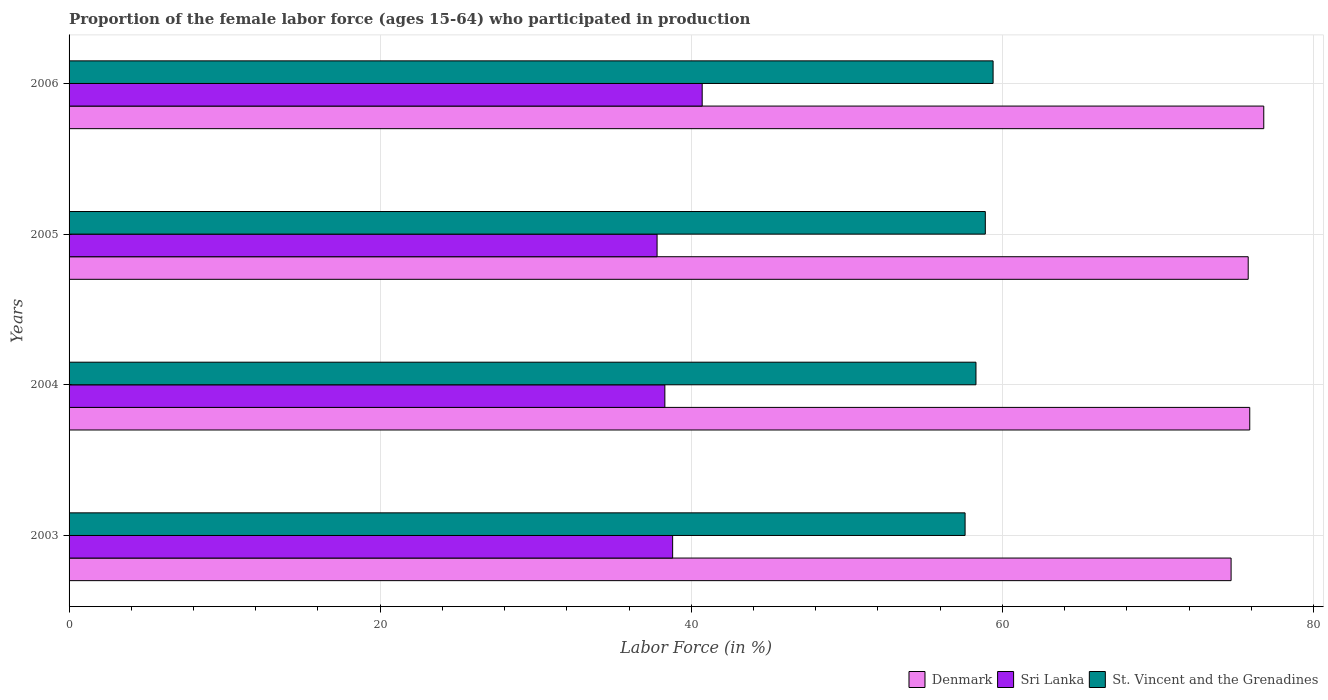How many different coloured bars are there?
Provide a short and direct response. 3. Are the number of bars per tick equal to the number of legend labels?
Make the answer very short. Yes. How many bars are there on the 2nd tick from the top?
Your answer should be very brief. 3. What is the label of the 2nd group of bars from the top?
Give a very brief answer. 2005. In how many cases, is the number of bars for a given year not equal to the number of legend labels?
Offer a terse response. 0. What is the proportion of the female labor force who participated in production in Denmark in 2004?
Keep it short and to the point. 75.9. Across all years, what is the maximum proportion of the female labor force who participated in production in Sri Lanka?
Your answer should be compact. 40.7. Across all years, what is the minimum proportion of the female labor force who participated in production in St. Vincent and the Grenadines?
Make the answer very short. 57.6. In which year was the proportion of the female labor force who participated in production in Denmark maximum?
Offer a terse response. 2006. What is the total proportion of the female labor force who participated in production in Sri Lanka in the graph?
Your answer should be compact. 155.6. What is the difference between the proportion of the female labor force who participated in production in Denmark in 2004 and that in 2006?
Provide a short and direct response. -0.9. What is the difference between the proportion of the female labor force who participated in production in St. Vincent and the Grenadines in 2004 and the proportion of the female labor force who participated in production in Denmark in 2006?
Your answer should be very brief. -18.5. What is the average proportion of the female labor force who participated in production in Denmark per year?
Your answer should be very brief. 75.8. In the year 2005, what is the difference between the proportion of the female labor force who participated in production in Denmark and proportion of the female labor force who participated in production in Sri Lanka?
Offer a very short reply. 38. In how many years, is the proportion of the female labor force who participated in production in Sri Lanka greater than 12 %?
Your answer should be compact. 4. What is the ratio of the proportion of the female labor force who participated in production in Sri Lanka in 2003 to that in 2006?
Provide a succinct answer. 0.95. What is the difference between the highest and the second highest proportion of the female labor force who participated in production in Denmark?
Keep it short and to the point. 0.9. What is the difference between the highest and the lowest proportion of the female labor force who participated in production in Denmark?
Offer a terse response. 2.1. In how many years, is the proportion of the female labor force who participated in production in Sri Lanka greater than the average proportion of the female labor force who participated in production in Sri Lanka taken over all years?
Your answer should be very brief. 1. Is the sum of the proportion of the female labor force who participated in production in Sri Lanka in 2005 and 2006 greater than the maximum proportion of the female labor force who participated in production in Denmark across all years?
Your answer should be very brief. Yes. What does the 1st bar from the top in 2005 represents?
Give a very brief answer. St. Vincent and the Grenadines. What does the 2nd bar from the bottom in 2006 represents?
Your answer should be very brief. Sri Lanka. Is it the case that in every year, the sum of the proportion of the female labor force who participated in production in Sri Lanka and proportion of the female labor force who participated in production in Denmark is greater than the proportion of the female labor force who participated in production in St. Vincent and the Grenadines?
Your response must be concise. Yes. Are all the bars in the graph horizontal?
Your response must be concise. Yes. How many years are there in the graph?
Give a very brief answer. 4. Are the values on the major ticks of X-axis written in scientific E-notation?
Offer a very short reply. No. Where does the legend appear in the graph?
Your response must be concise. Bottom right. How many legend labels are there?
Ensure brevity in your answer.  3. What is the title of the graph?
Give a very brief answer. Proportion of the female labor force (ages 15-64) who participated in production. What is the label or title of the Y-axis?
Provide a succinct answer. Years. What is the Labor Force (in %) of Denmark in 2003?
Provide a short and direct response. 74.7. What is the Labor Force (in %) in Sri Lanka in 2003?
Provide a succinct answer. 38.8. What is the Labor Force (in %) of St. Vincent and the Grenadines in 2003?
Offer a terse response. 57.6. What is the Labor Force (in %) of Denmark in 2004?
Offer a very short reply. 75.9. What is the Labor Force (in %) in Sri Lanka in 2004?
Offer a very short reply. 38.3. What is the Labor Force (in %) in St. Vincent and the Grenadines in 2004?
Your answer should be very brief. 58.3. What is the Labor Force (in %) in Denmark in 2005?
Keep it short and to the point. 75.8. What is the Labor Force (in %) of Sri Lanka in 2005?
Make the answer very short. 37.8. What is the Labor Force (in %) of St. Vincent and the Grenadines in 2005?
Your answer should be very brief. 58.9. What is the Labor Force (in %) of Denmark in 2006?
Provide a succinct answer. 76.8. What is the Labor Force (in %) of Sri Lanka in 2006?
Ensure brevity in your answer.  40.7. What is the Labor Force (in %) in St. Vincent and the Grenadines in 2006?
Your response must be concise. 59.4. Across all years, what is the maximum Labor Force (in %) of Denmark?
Provide a short and direct response. 76.8. Across all years, what is the maximum Labor Force (in %) in Sri Lanka?
Make the answer very short. 40.7. Across all years, what is the maximum Labor Force (in %) of St. Vincent and the Grenadines?
Make the answer very short. 59.4. Across all years, what is the minimum Labor Force (in %) of Denmark?
Make the answer very short. 74.7. Across all years, what is the minimum Labor Force (in %) of Sri Lanka?
Your response must be concise. 37.8. Across all years, what is the minimum Labor Force (in %) in St. Vincent and the Grenadines?
Ensure brevity in your answer.  57.6. What is the total Labor Force (in %) of Denmark in the graph?
Make the answer very short. 303.2. What is the total Labor Force (in %) in Sri Lanka in the graph?
Ensure brevity in your answer.  155.6. What is the total Labor Force (in %) of St. Vincent and the Grenadines in the graph?
Provide a succinct answer. 234.2. What is the difference between the Labor Force (in %) in Denmark in 2003 and that in 2004?
Offer a very short reply. -1.2. What is the difference between the Labor Force (in %) of St. Vincent and the Grenadines in 2003 and that in 2005?
Provide a short and direct response. -1.3. What is the difference between the Labor Force (in %) in St. Vincent and the Grenadines in 2003 and that in 2006?
Keep it short and to the point. -1.8. What is the difference between the Labor Force (in %) in St. Vincent and the Grenadines in 2004 and that in 2005?
Provide a succinct answer. -0.6. What is the difference between the Labor Force (in %) of Sri Lanka in 2004 and that in 2006?
Your answer should be compact. -2.4. What is the difference between the Labor Force (in %) in Denmark in 2005 and that in 2006?
Your answer should be compact. -1. What is the difference between the Labor Force (in %) of Sri Lanka in 2005 and that in 2006?
Your response must be concise. -2.9. What is the difference between the Labor Force (in %) of Denmark in 2003 and the Labor Force (in %) of Sri Lanka in 2004?
Offer a terse response. 36.4. What is the difference between the Labor Force (in %) in Denmark in 2003 and the Labor Force (in %) in St. Vincent and the Grenadines in 2004?
Keep it short and to the point. 16.4. What is the difference between the Labor Force (in %) in Sri Lanka in 2003 and the Labor Force (in %) in St. Vincent and the Grenadines in 2004?
Your response must be concise. -19.5. What is the difference between the Labor Force (in %) of Denmark in 2003 and the Labor Force (in %) of Sri Lanka in 2005?
Your answer should be very brief. 36.9. What is the difference between the Labor Force (in %) in Sri Lanka in 2003 and the Labor Force (in %) in St. Vincent and the Grenadines in 2005?
Keep it short and to the point. -20.1. What is the difference between the Labor Force (in %) of Denmark in 2003 and the Labor Force (in %) of Sri Lanka in 2006?
Offer a very short reply. 34. What is the difference between the Labor Force (in %) of Denmark in 2003 and the Labor Force (in %) of St. Vincent and the Grenadines in 2006?
Make the answer very short. 15.3. What is the difference between the Labor Force (in %) of Sri Lanka in 2003 and the Labor Force (in %) of St. Vincent and the Grenadines in 2006?
Offer a terse response. -20.6. What is the difference between the Labor Force (in %) in Denmark in 2004 and the Labor Force (in %) in Sri Lanka in 2005?
Provide a short and direct response. 38.1. What is the difference between the Labor Force (in %) of Sri Lanka in 2004 and the Labor Force (in %) of St. Vincent and the Grenadines in 2005?
Your answer should be compact. -20.6. What is the difference between the Labor Force (in %) of Denmark in 2004 and the Labor Force (in %) of Sri Lanka in 2006?
Your response must be concise. 35.2. What is the difference between the Labor Force (in %) of Denmark in 2004 and the Labor Force (in %) of St. Vincent and the Grenadines in 2006?
Your response must be concise. 16.5. What is the difference between the Labor Force (in %) of Sri Lanka in 2004 and the Labor Force (in %) of St. Vincent and the Grenadines in 2006?
Ensure brevity in your answer.  -21.1. What is the difference between the Labor Force (in %) in Denmark in 2005 and the Labor Force (in %) in Sri Lanka in 2006?
Your answer should be very brief. 35.1. What is the difference between the Labor Force (in %) in Denmark in 2005 and the Labor Force (in %) in St. Vincent and the Grenadines in 2006?
Provide a short and direct response. 16.4. What is the difference between the Labor Force (in %) in Sri Lanka in 2005 and the Labor Force (in %) in St. Vincent and the Grenadines in 2006?
Keep it short and to the point. -21.6. What is the average Labor Force (in %) of Denmark per year?
Give a very brief answer. 75.8. What is the average Labor Force (in %) in Sri Lanka per year?
Offer a very short reply. 38.9. What is the average Labor Force (in %) in St. Vincent and the Grenadines per year?
Offer a very short reply. 58.55. In the year 2003, what is the difference between the Labor Force (in %) of Denmark and Labor Force (in %) of Sri Lanka?
Offer a terse response. 35.9. In the year 2003, what is the difference between the Labor Force (in %) in Denmark and Labor Force (in %) in St. Vincent and the Grenadines?
Your response must be concise. 17.1. In the year 2003, what is the difference between the Labor Force (in %) in Sri Lanka and Labor Force (in %) in St. Vincent and the Grenadines?
Your answer should be very brief. -18.8. In the year 2004, what is the difference between the Labor Force (in %) of Denmark and Labor Force (in %) of Sri Lanka?
Make the answer very short. 37.6. In the year 2004, what is the difference between the Labor Force (in %) in Denmark and Labor Force (in %) in St. Vincent and the Grenadines?
Provide a short and direct response. 17.6. In the year 2004, what is the difference between the Labor Force (in %) of Sri Lanka and Labor Force (in %) of St. Vincent and the Grenadines?
Your response must be concise. -20. In the year 2005, what is the difference between the Labor Force (in %) in Denmark and Labor Force (in %) in Sri Lanka?
Your answer should be compact. 38. In the year 2005, what is the difference between the Labor Force (in %) in Sri Lanka and Labor Force (in %) in St. Vincent and the Grenadines?
Keep it short and to the point. -21.1. In the year 2006, what is the difference between the Labor Force (in %) of Denmark and Labor Force (in %) of Sri Lanka?
Offer a terse response. 36.1. In the year 2006, what is the difference between the Labor Force (in %) in Sri Lanka and Labor Force (in %) in St. Vincent and the Grenadines?
Provide a short and direct response. -18.7. What is the ratio of the Labor Force (in %) of Denmark in 2003 to that in 2004?
Provide a short and direct response. 0.98. What is the ratio of the Labor Force (in %) of Sri Lanka in 2003 to that in 2004?
Ensure brevity in your answer.  1.01. What is the ratio of the Labor Force (in %) of St. Vincent and the Grenadines in 2003 to that in 2004?
Provide a short and direct response. 0.99. What is the ratio of the Labor Force (in %) in Denmark in 2003 to that in 2005?
Your answer should be compact. 0.99. What is the ratio of the Labor Force (in %) of Sri Lanka in 2003 to that in 2005?
Your response must be concise. 1.03. What is the ratio of the Labor Force (in %) in St. Vincent and the Grenadines in 2003 to that in 2005?
Make the answer very short. 0.98. What is the ratio of the Labor Force (in %) in Denmark in 2003 to that in 2006?
Give a very brief answer. 0.97. What is the ratio of the Labor Force (in %) of Sri Lanka in 2003 to that in 2006?
Your response must be concise. 0.95. What is the ratio of the Labor Force (in %) of St. Vincent and the Grenadines in 2003 to that in 2006?
Make the answer very short. 0.97. What is the ratio of the Labor Force (in %) in Sri Lanka in 2004 to that in 2005?
Offer a very short reply. 1.01. What is the ratio of the Labor Force (in %) in St. Vincent and the Grenadines in 2004 to that in 2005?
Your answer should be very brief. 0.99. What is the ratio of the Labor Force (in %) in Denmark in 2004 to that in 2006?
Offer a very short reply. 0.99. What is the ratio of the Labor Force (in %) of Sri Lanka in 2004 to that in 2006?
Ensure brevity in your answer.  0.94. What is the ratio of the Labor Force (in %) in St. Vincent and the Grenadines in 2004 to that in 2006?
Give a very brief answer. 0.98. What is the ratio of the Labor Force (in %) in Denmark in 2005 to that in 2006?
Provide a succinct answer. 0.99. What is the ratio of the Labor Force (in %) of Sri Lanka in 2005 to that in 2006?
Ensure brevity in your answer.  0.93. What is the difference between the highest and the second highest Labor Force (in %) of Sri Lanka?
Provide a succinct answer. 1.9. What is the difference between the highest and the second highest Labor Force (in %) in St. Vincent and the Grenadines?
Keep it short and to the point. 0.5. What is the difference between the highest and the lowest Labor Force (in %) of Denmark?
Your answer should be very brief. 2.1. What is the difference between the highest and the lowest Labor Force (in %) of Sri Lanka?
Your response must be concise. 2.9. What is the difference between the highest and the lowest Labor Force (in %) in St. Vincent and the Grenadines?
Keep it short and to the point. 1.8. 